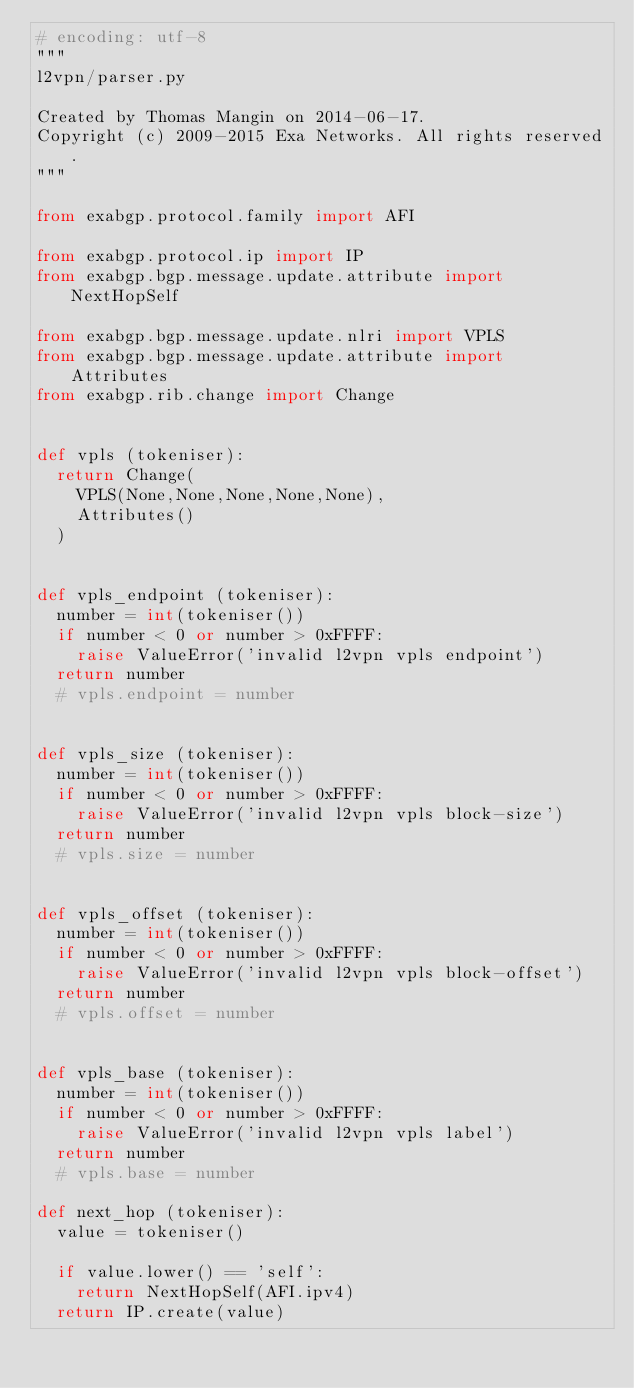Convert code to text. <code><loc_0><loc_0><loc_500><loc_500><_Python_># encoding: utf-8
"""
l2vpn/parser.py

Created by Thomas Mangin on 2014-06-17.
Copyright (c) 2009-2015 Exa Networks. All rights reserved.
"""

from exabgp.protocol.family import AFI

from exabgp.protocol.ip import IP
from exabgp.bgp.message.update.attribute import NextHopSelf

from exabgp.bgp.message.update.nlri import VPLS
from exabgp.bgp.message.update.attribute import Attributes
from exabgp.rib.change import Change


def vpls (tokeniser):
	return Change(
		VPLS(None,None,None,None,None),
		Attributes()
	)


def vpls_endpoint (tokeniser):
	number = int(tokeniser())
	if number < 0 or number > 0xFFFF:
		raise ValueError('invalid l2vpn vpls endpoint')
	return number
	# vpls.endpoint = number


def vpls_size (tokeniser):
	number = int(tokeniser())
	if number < 0 or number > 0xFFFF:
		raise ValueError('invalid l2vpn vpls block-size')
	return number
	# vpls.size = number


def vpls_offset (tokeniser):
	number = int(tokeniser())
	if number < 0 or number > 0xFFFF:
		raise ValueError('invalid l2vpn vpls block-offset')
	return number
	# vpls.offset = number


def vpls_base (tokeniser):
	number = int(tokeniser())
	if number < 0 or number > 0xFFFF:
		raise ValueError('invalid l2vpn vpls label')
	return number
	# vpls.base = number

def next_hop (tokeniser):
	value = tokeniser()

	if value.lower() == 'self':
		return NextHopSelf(AFI.ipv4)
	return IP.create(value)
</code> 